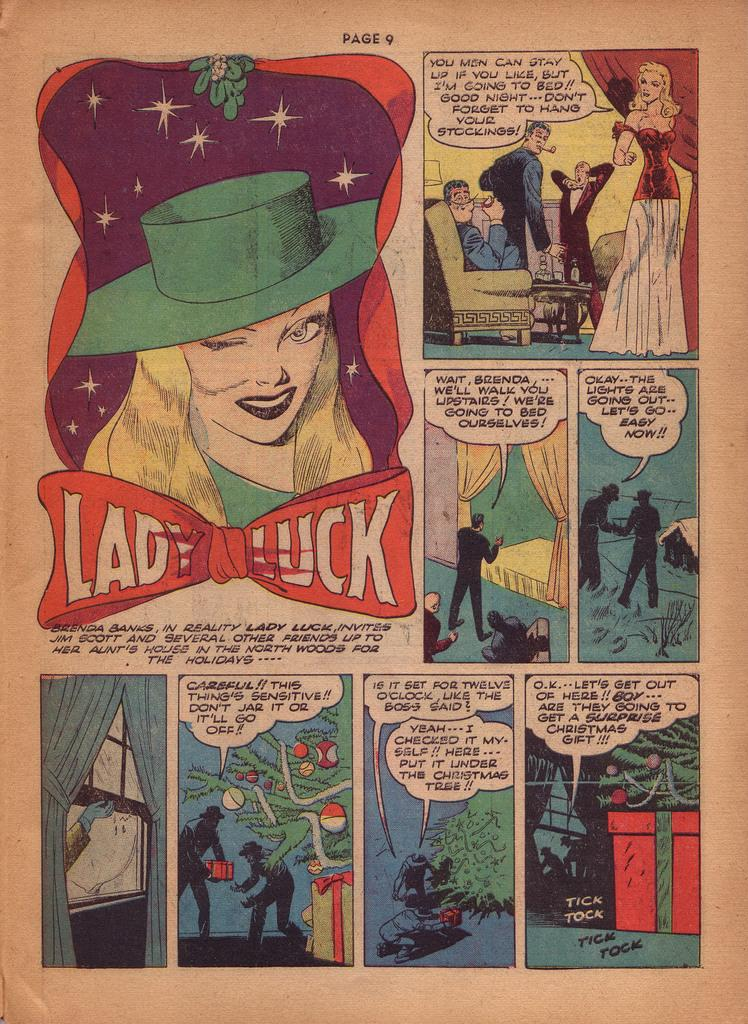<image>
Offer a succinct explanation of the picture presented. Brenda Banks' alter ego is Lady Luck and appeared on Page 9. 